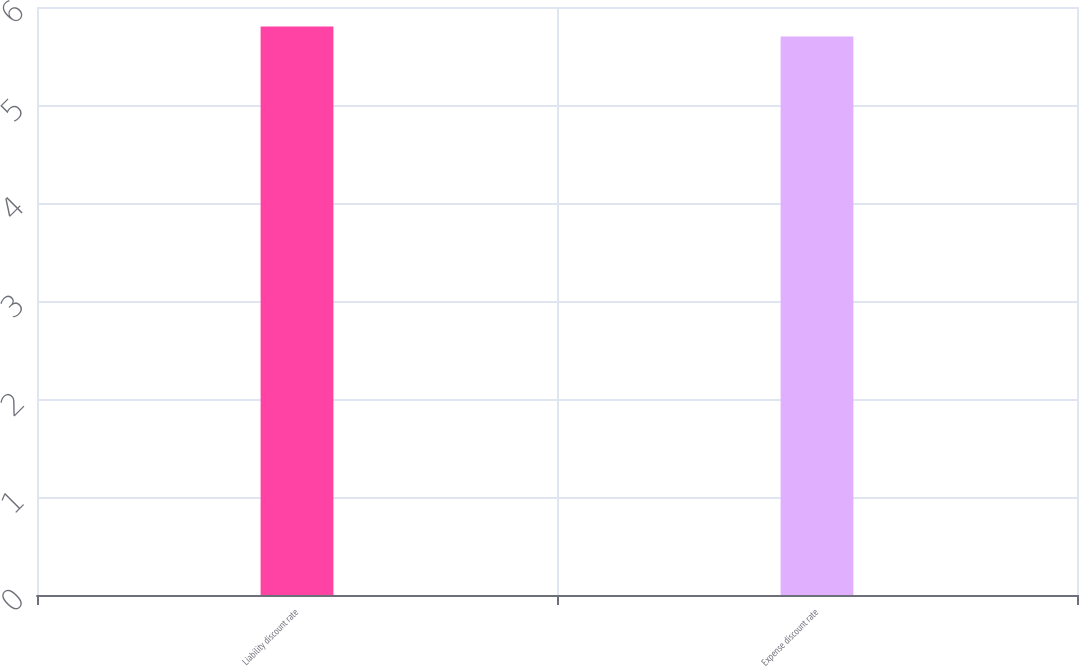Convert chart. <chart><loc_0><loc_0><loc_500><loc_500><bar_chart><fcel>Liability discount rate<fcel>Expense discount rate<nl><fcel>5.8<fcel>5.7<nl></chart> 